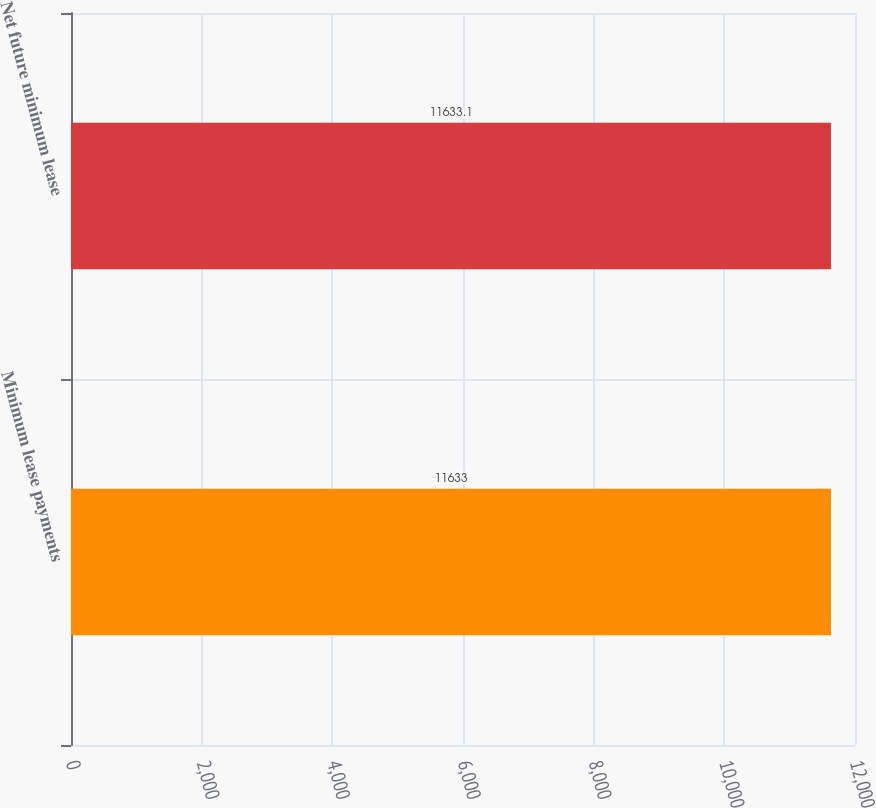Convert chart. <chart><loc_0><loc_0><loc_500><loc_500><bar_chart><fcel>Minimum lease payments<fcel>Net future minimum lease<nl><fcel>11633<fcel>11633.1<nl></chart> 